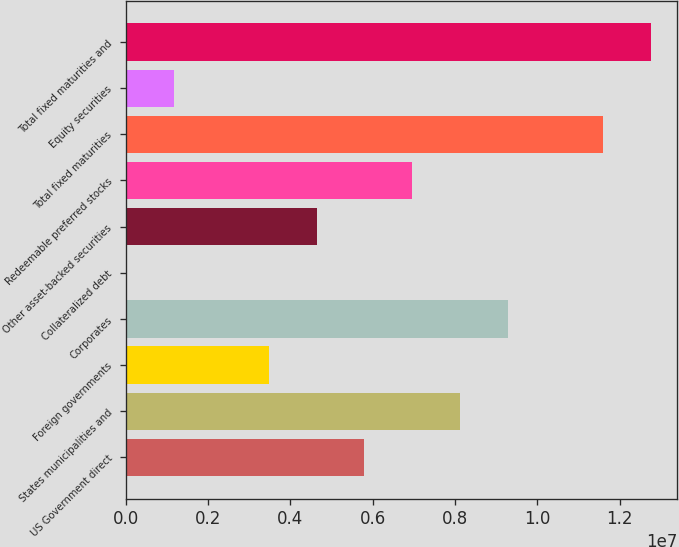Convert chart to OTSL. <chart><loc_0><loc_0><loc_500><loc_500><bar_chart><fcel>US Government direct<fcel>States municipalities and<fcel>Foreign governments<fcel>Corporates<fcel>Collateralized debt<fcel>Other asset-backed securities<fcel>Redeemable preferred stocks<fcel>Total fixed maturities<fcel>Equity securities<fcel>Total fixed maturities and<nl><fcel>5.7969e+06<fcel>8.11567e+06<fcel>3.47814e+06<fcel>9.27505e+06<fcel>0.33<fcel>4.63752e+06<fcel>6.95628e+06<fcel>1.15938e+07<fcel>1.15938e+06<fcel>1.27532e+07<nl></chart> 